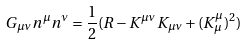<formula> <loc_0><loc_0><loc_500><loc_500>G _ { \mu \nu } n ^ { \mu } n ^ { \nu } = { \frac { 1 } { 2 } } ( R - K ^ { \mu \nu } K _ { \mu \nu } + ( K _ { \mu } ^ { \mu } ) ^ { 2 } )</formula> 